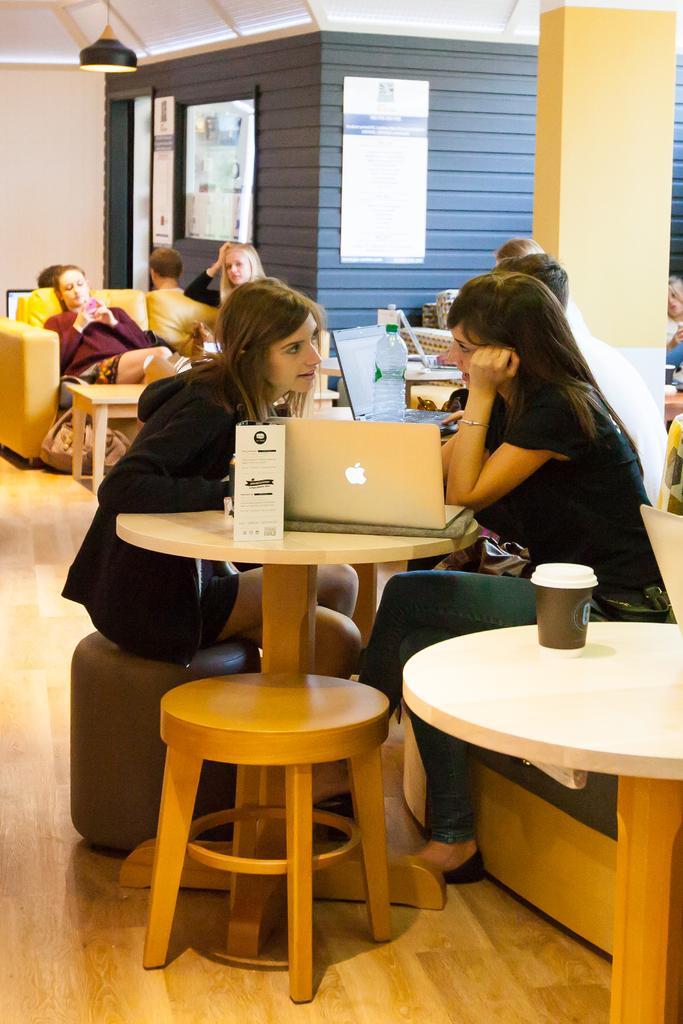Can you describe this image briefly? This is a picture taken in a room, there are a group of people sitting on a chair. There are two women sitting on a chair in front of this two women there is a table on the table there is a laptop and paper and bottle. Background of this people is a pillar and a wall. 